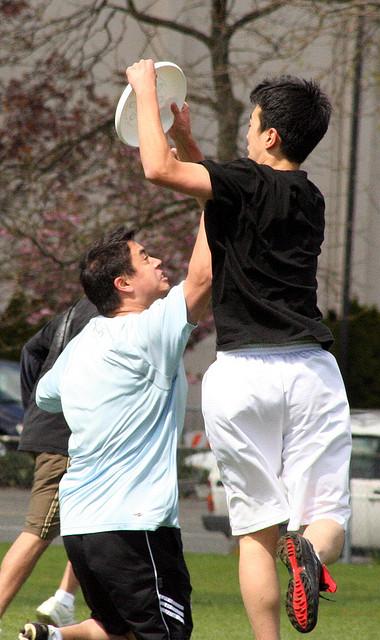What is the person in white shorts holding?
Quick response, please. Frisbee. Are they twins?
Give a very brief answer. No. Are both of the man's hands raised?
Answer briefly. Yes. What is the color of freebee?
Short answer required. White. Who caught the Frisbee?
Keep it brief. Black shirt. How many people are there?
Quick response, please. 3. What is the man holding?
Short answer required. Frisbee. 